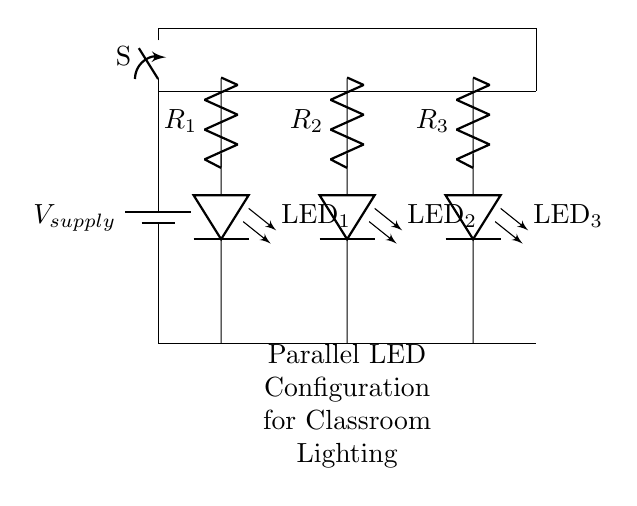What type of circuit configuration is shown? The circuit diagram represents a parallel configuration, as evidenced by the multiple branches of LEDs connected directly to the same voltage source. Each LED has its own path for current, characteristic of parallel circuits.
Answer: Parallel How many LED lights are in the circuit? The circuit diagram shows three LED lights, labeled LED1, LED2, and LED3, each in its own parallel branch connected to the power supply.
Answer: Three What is the function of the resistors in the circuit? The resistors, labeled R1, R2, and R3, are used to limit the current flowing through each LED to prevent them from burning out, which is crucial in maintaining the longevity of the LEDs.
Answer: Current limiting What happens if one LED burns out? If one LED burns out, the other LEDs will remain illuminated because each LED operates independently in its parallel path. This is a key advantage of parallel circuits compared to series circuits where one failure affects the entire circuit.
Answer: Others remain lit What is the total current supplied from the battery? The total current supplied from the battery is the sum of the currents through each LED branch. While the values of resistors are not specified, the total current can be derived from the total voltage and the equivalent resistance, calculated using Ohm's law.
Answer: Sum of LED currents Which component allows the circuit to be turned on and off? The component that allows the circuit to be turned on and off is the switch, labeled S. It breaks or completes the circuit, controlling the flow of electricity to the LEDs.
Answer: Switch 